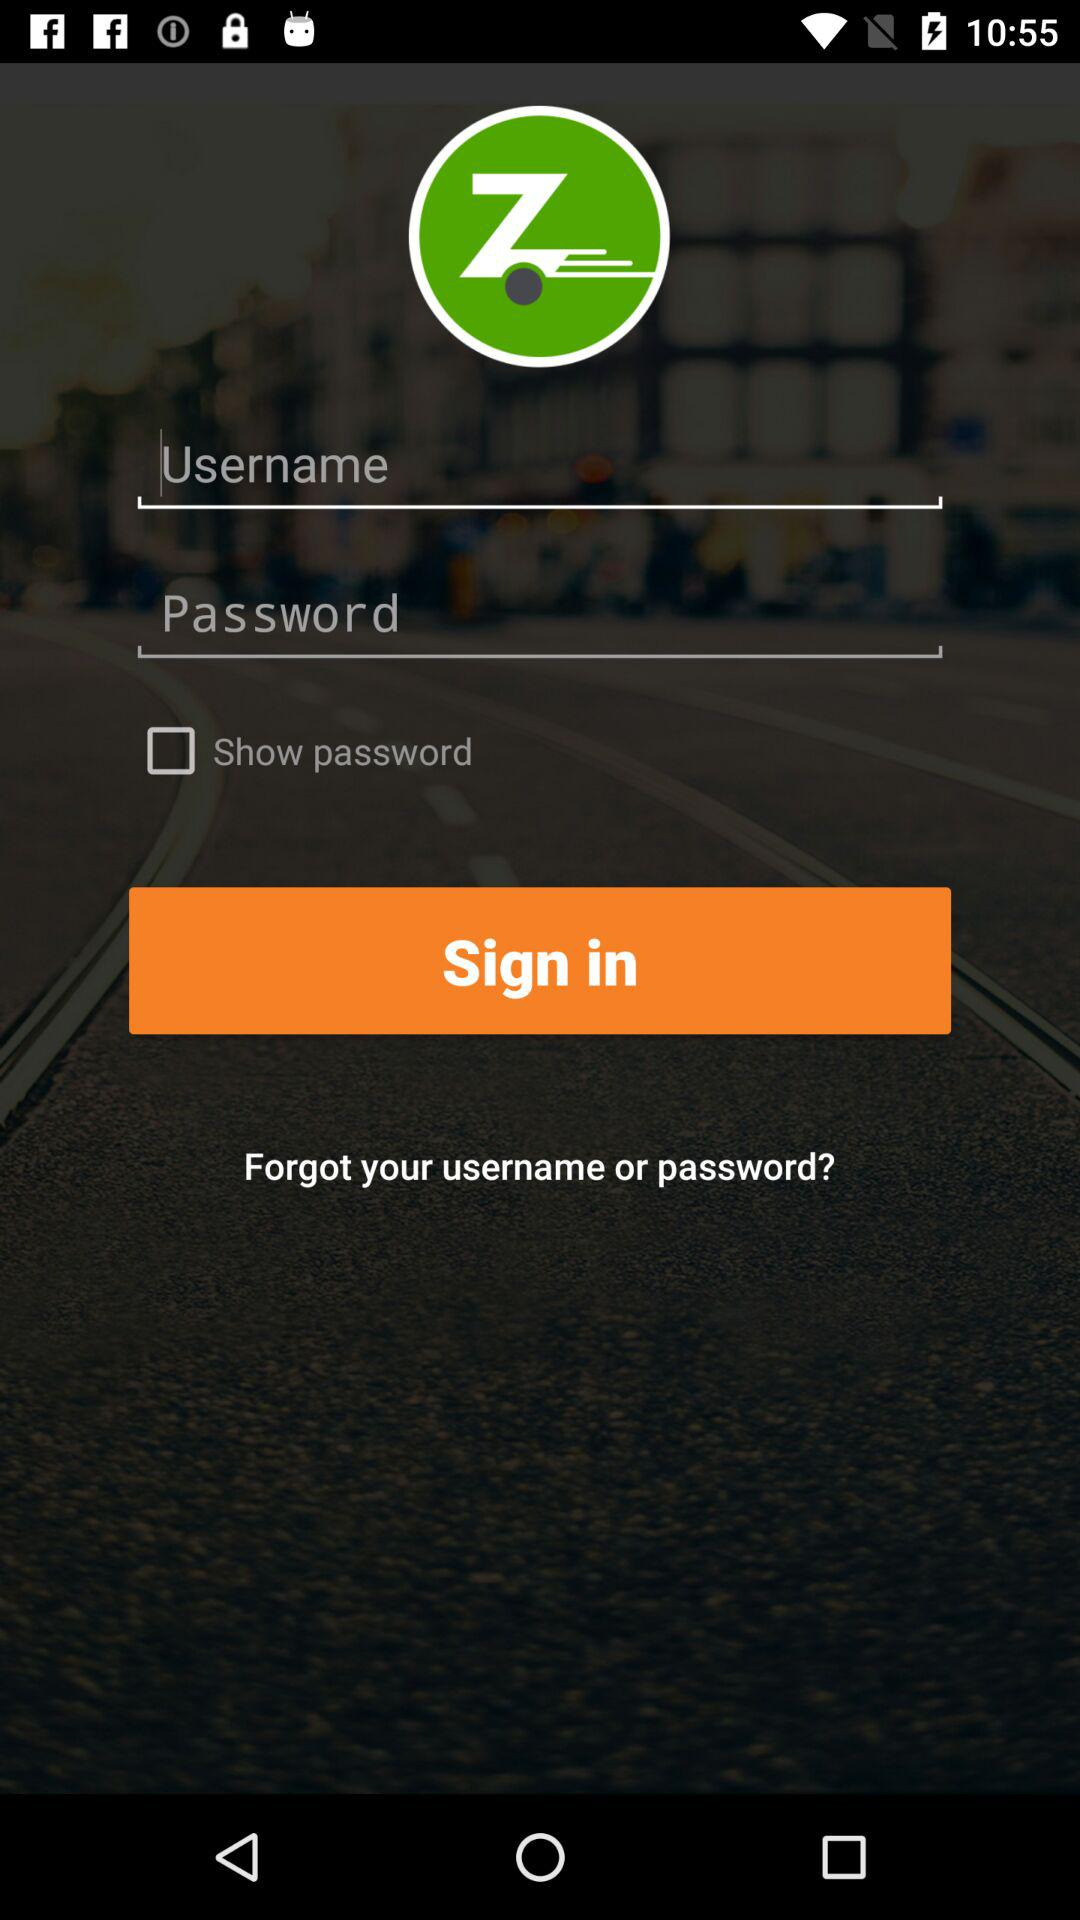What is the entered username?
When the provided information is insufficient, respond with <no answer>. <no answer> 